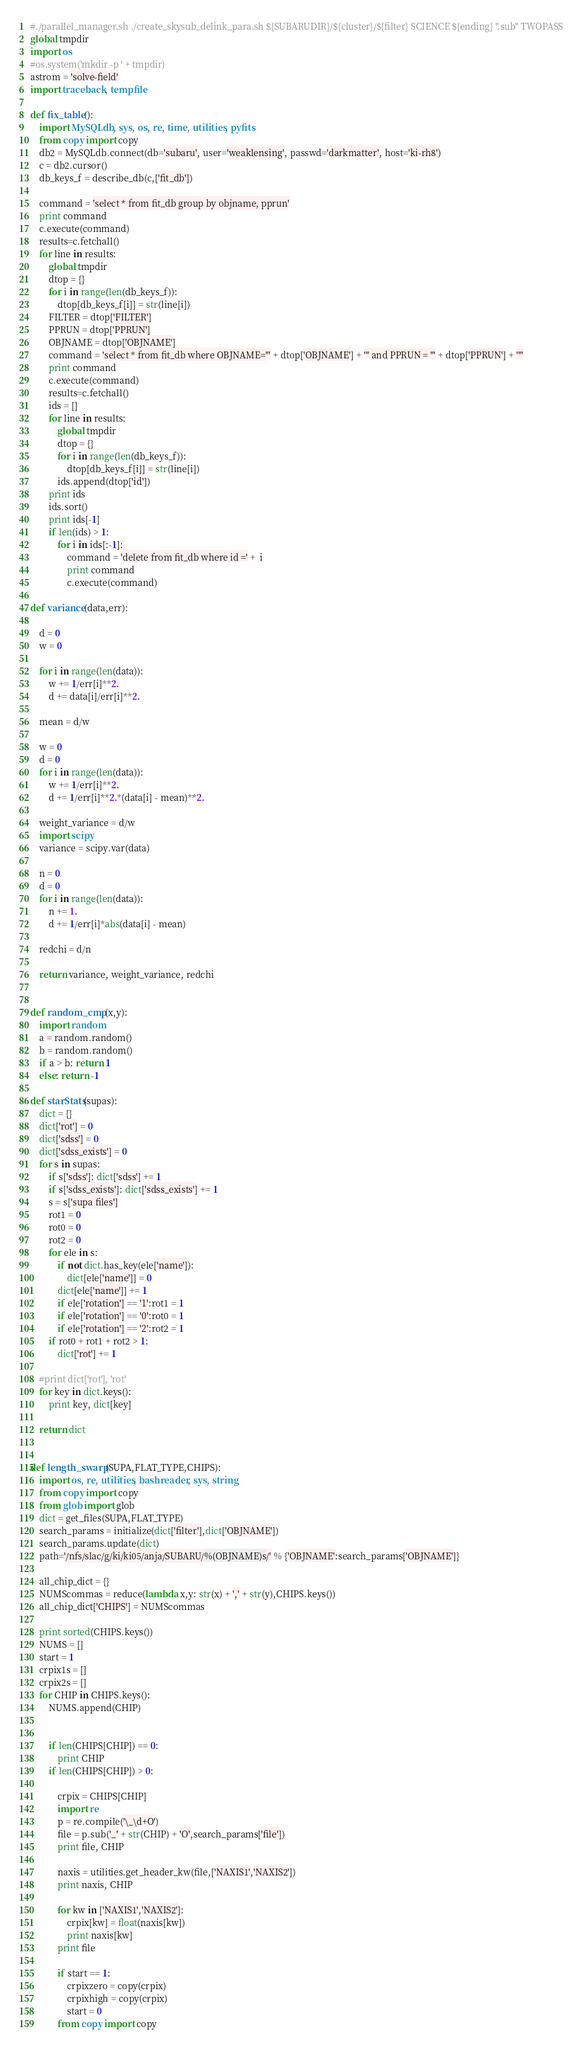Convert code to text. <code><loc_0><loc_0><loc_500><loc_500><_Python_>#./parallel_manager.sh ./create_skysub_delink_para.sh ${SUBARUDIR}/${cluster}/${filter} SCIENCE ${ending} ".sub" TWOPASS
global tmpdir
import os
#os.system('mkdir -p ' + tmpdir)
astrom = 'solve-field'
import traceback, tempfile

def fix_table():
    import MySQLdb, sys, os, re, time, utilities, pyfits                                       
    from copy import copy
    db2 = MySQLdb.connect(db='subaru', user='weaklensing', passwd='darkmatter', host='ki-rh8')
    c = db2.cursor()
    db_keys_f = describe_db(c,['fit_db'])

    command = 'select * from fit_db group by objname, pprun'
    print command          
    c.execute(command)
    results=c.fetchall()
    for line in results:
        global tmpdir
        dtop = {}  
        for i in range(len(db_keys_f)):
            dtop[db_keys_f[i]] = str(line[i])
        FILTER = dtop['FILTER']
        PPRUN = dtop['PPRUN']
        OBJNAME = dtop['OBJNAME']
        command = 'select * from fit_db where OBJNAME="' + dtop['OBJNAME'] + '" and PPRUN = "' + dtop['PPRUN'] + '"' 
        print command          
        c.execute(command)
        results=c.fetchall()
        ids = []
        for line in results:
            global tmpdir
            dtop = {}  
            for i in range(len(db_keys_f)):
                dtop[db_keys_f[i]] = str(line[i])
            ids.append(dtop['id'])
        print ids
        ids.sort()
        print ids[-1]
        if len(ids) > 1:
            for i in ids[:-1]:
                command = 'delete from fit_db where id =' +  i                
                print command
                c.execute(command)

def variance(data,err):

    d = 0
    w = 0

    for i in range(len(data)):
        w += 1/err[i]**2.
        d += data[i]/err[i]**2.

    mean = d/w

    w = 0
    d = 0
    for i in range(len(data)):
        w += 1/err[i]**2.
        d += 1/err[i]**2.*(data[i] - mean)**2.

    weight_variance = d/w    
    import scipy
    variance = scipy.var(data)

    n = 0
    d = 0
    for i in range(len(data)):
        n += 1.
        d += 1/err[i]*abs(data[i] - mean)

    redchi = d/n

    return variance, weight_variance, redchi


def random_cmp(x,y):
    import random
    a = random.random()
    b = random.random()
    if a > b: return 1
    else: return -1

def starStats(supas):
    dict = {} 
    dict['rot'] = 0
    dict['sdss'] = 0
    dict['sdss_exists'] = 0
    for s in supas:
        if s['sdss']: dict['sdss'] += 1
        if s['sdss_exists']: dict['sdss_exists'] += 1
        s = s['supa files']
        rot1 = 0
        rot0 = 0
        rot2 = 0
        for ele in s:
            if not dict.has_key(ele['name']):
                dict[ele['name']] = 0 
            dict[ele['name']] += 1
            if ele['rotation'] == '1':rot1 = 1
            if ele['rotation'] == '0':rot0 = 1
            if ele['rotation'] == '2':rot2 = 1
        if rot0 + rot1 + rot2 > 1:
            dict['rot'] += 1
            
    #print dict['rot'], 'rot'
    for key in dict.keys():
        print key, dict[key]

    return dict


def length_swarp(SUPA,FLAT_TYPE,CHIPS):
    import os, re, utilities, bashreader, sys, string
    from copy import copy
    from glob import glob
    dict = get_files(SUPA,FLAT_TYPE)
    search_params = initialize(dict['filter'],dict['OBJNAME'])
    search_params.update(dict)
    path='/nfs/slac/g/ki/ki05/anja/SUBARU/%(OBJNAME)s/' % {'OBJNAME':search_params['OBJNAME']}

    all_chip_dict = {}
    NUMScommas = reduce(lambda x,y: str(x) + ',' + str(y),CHIPS.keys())
    all_chip_dict['CHIPS'] = NUMScommas

    print sorted(CHIPS.keys())
    NUMS = []
    start = 1
    crpix1s = []
    crpix2s = []
    for CHIP in CHIPS.keys():
        NUMS.append(CHIP)        
        

        if len(CHIPS[CHIP]) == 0:
            print CHIP
        if len(CHIPS[CHIP]) > 0:

            crpix = CHIPS[CHIP] 
            import re                                                                                                                               
            p = re.compile('\_\d+O')
            file = p.sub('_' + str(CHIP) + 'O',search_params['file'])
            print file, CHIP
            
            naxis = utilities.get_header_kw(file,['NAXIS1','NAXIS2'])
            print naxis, CHIP
            
            for kw in ['NAXIS1','NAXIS2']:
                crpix[kw] = float(naxis[kw])
                print naxis[kw]
            print file
            
            if start == 1:
                crpixzero = copy(crpix)
                crpixhigh = copy(crpix)
                start = 0
            from copy import copy </code> 